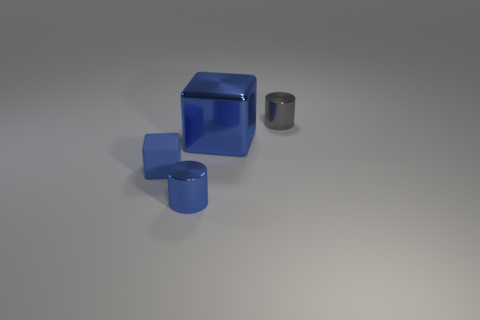Is there a gray shiny object behind the small metallic thing that is on the left side of the big metal cube?
Provide a short and direct response. Yes. There is a gray object; does it have the same shape as the blue thing that is behind the tiny cube?
Ensure brevity in your answer.  No. There is a metallic thing that is both in front of the small gray cylinder and behind the tiny blue matte object; what is its size?
Provide a short and direct response. Large. Are there any large cylinders made of the same material as the small blue cylinder?
Provide a short and direct response. No. What size is the cylinder that is the same color as the metallic block?
Your answer should be compact. Small. There is a thing that is left of the tiny metal cylinder that is to the left of the large block; what is it made of?
Provide a short and direct response. Rubber. How many tiny balls have the same color as the big metallic cube?
Your answer should be compact. 0. The blue block that is made of the same material as the gray thing is what size?
Your answer should be compact. Large. What is the shape of the blue thing that is in front of the tiny blue block?
Provide a short and direct response. Cylinder. What size is the other metal thing that is the same shape as the small gray thing?
Provide a succinct answer. Small. 